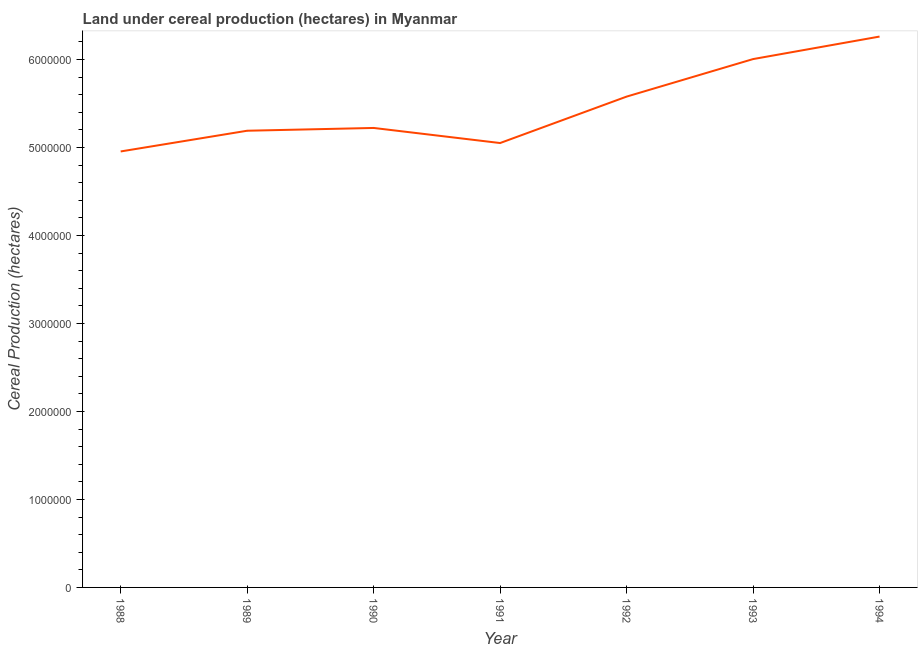What is the land under cereal production in 1988?
Your answer should be compact. 4.95e+06. Across all years, what is the maximum land under cereal production?
Ensure brevity in your answer.  6.26e+06. Across all years, what is the minimum land under cereal production?
Your answer should be compact. 4.95e+06. In which year was the land under cereal production maximum?
Give a very brief answer. 1994. In which year was the land under cereal production minimum?
Offer a terse response. 1988. What is the sum of the land under cereal production?
Keep it short and to the point. 3.83e+07. What is the difference between the land under cereal production in 1988 and 1994?
Your response must be concise. -1.31e+06. What is the average land under cereal production per year?
Offer a terse response. 5.47e+06. What is the median land under cereal production?
Offer a terse response. 5.22e+06. In how many years, is the land under cereal production greater than 1600000 hectares?
Your answer should be compact. 7. Do a majority of the years between 1993 and 1989 (inclusive) have land under cereal production greater than 400000 hectares?
Offer a very short reply. Yes. What is the ratio of the land under cereal production in 1991 to that in 1993?
Your answer should be very brief. 0.84. What is the difference between the highest and the second highest land under cereal production?
Offer a terse response. 2.56e+05. What is the difference between the highest and the lowest land under cereal production?
Keep it short and to the point. 1.31e+06. In how many years, is the land under cereal production greater than the average land under cereal production taken over all years?
Keep it short and to the point. 3. How many lines are there?
Ensure brevity in your answer.  1. How many years are there in the graph?
Keep it short and to the point. 7. Are the values on the major ticks of Y-axis written in scientific E-notation?
Ensure brevity in your answer.  No. What is the title of the graph?
Provide a short and direct response. Land under cereal production (hectares) in Myanmar. What is the label or title of the Y-axis?
Your response must be concise. Cereal Production (hectares). What is the Cereal Production (hectares) of 1988?
Offer a very short reply. 4.95e+06. What is the Cereal Production (hectares) in 1989?
Offer a very short reply. 5.19e+06. What is the Cereal Production (hectares) of 1990?
Your answer should be compact. 5.22e+06. What is the Cereal Production (hectares) in 1991?
Provide a short and direct response. 5.05e+06. What is the Cereal Production (hectares) of 1992?
Your answer should be compact. 5.58e+06. What is the Cereal Production (hectares) of 1993?
Ensure brevity in your answer.  6.00e+06. What is the Cereal Production (hectares) of 1994?
Offer a very short reply. 6.26e+06. What is the difference between the Cereal Production (hectares) in 1988 and 1989?
Offer a very short reply. -2.35e+05. What is the difference between the Cereal Production (hectares) in 1988 and 1990?
Your answer should be very brief. -2.67e+05. What is the difference between the Cereal Production (hectares) in 1988 and 1991?
Keep it short and to the point. -9.56e+04. What is the difference between the Cereal Production (hectares) in 1988 and 1992?
Provide a short and direct response. -6.23e+05. What is the difference between the Cereal Production (hectares) in 1988 and 1993?
Your response must be concise. -1.05e+06. What is the difference between the Cereal Production (hectares) in 1988 and 1994?
Make the answer very short. -1.31e+06. What is the difference between the Cereal Production (hectares) in 1989 and 1990?
Your response must be concise. -3.17e+04. What is the difference between the Cereal Production (hectares) in 1989 and 1991?
Ensure brevity in your answer.  1.40e+05. What is the difference between the Cereal Production (hectares) in 1989 and 1992?
Your answer should be very brief. -3.88e+05. What is the difference between the Cereal Production (hectares) in 1989 and 1993?
Provide a succinct answer. -8.14e+05. What is the difference between the Cereal Production (hectares) in 1989 and 1994?
Offer a very short reply. -1.07e+06. What is the difference between the Cereal Production (hectares) in 1990 and 1991?
Give a very brief answer. 1.71e+05. What is the difference between the Cereal Production (hectares) in 1990 and 1992?
Provide a short and direct response. -3.56e+05. What is the difference between the Cereal Production (hectares) in 1990 and 1993?
Keep it short and to the point. -7.83e+05. What is the difference between the Cereal Production (hectares) in 1990 and 1994?
Make the answer very short. -1.04e+06. What is the difference between the Cereal Production (hectares) in 1991 and 1992?
Offer a terse response. -5.28e+05. What is the difference between the Cereal Production (hectares) in 1991 and 1993?
Offer a terse response. -9.54e+05. What is the difference between the Cereal Production (hectares) in 1991 and 1994?
Your answer should be very brief. -1.21e+06. What is the difference between the Cereal Production (hectares) in 1992 and 1993?
Your response must be concise. -4.26e+05. What is the difference between the Cereal Production (hectares) in 1992 and 1994?
Ensure brevity in your answer.  -6.82e+05. What is the difference between the Cereal Production (hectares) in 1993 and 1994?
Make the answer very short. -2.56e+05. What is the ratio of the Cereal Production (hectares) in 1988 to that in 1989?
Provide a succinct answer. 0.95. What is the ratio of the Cereal Production (hectares) in 1988 to that in 1990?
Your response must be concise. 0.95. What is the ratio of the Cereal Production (hectares) in 1988 to that in 1992?
Keep it short and to the point. 0.89. What is the ratio of the Cereal Production (hectares) in 1988 to that in 1993?
Provide a short and direct response. 0.82. What is the ratio of the Cereal Production (hectares) in 1988 to that in 1994?
Offer a terse response. 0.79. What is the ratio of the Cereal Production (hectares) in 1989 to that in 1991?
Offer a very short reply. 1.03. What is the ratio of the Cereal Production (hectares) in 1989 to that in 1993?
Your answer should be very brief. 0.86. What is the ratio of the Cereal Production (hectares) in 1989 to that in 1994?
Keep it short and to the point. 0.83. What is the ratio of the Cereal Production (hectares) in 1990 to that in 1991?
Your answer should be compact. 1.03. What is the ratio of the Cereal Production (hectares) in 1990 to that in 1992?
Offer a terse response. 0.94. What is the ratio of the Cereal Production (hectares) in 1990 to that in 1993?
Make the answer very short. 0.87. What is the ratio of the Cereal Production (hectares) in 1990 to that in 1994?
Provide a short and direct response. 0.83. What is the ratio of the Cereal Production (hectares) in 1991 to that in 1992?
Provide a short and direct response. 0.91. What is the ratio of the Cereal Production (hectares) in 1991 to that in 1993?
Your response must be concise. 0.84. What is the ratio of the Cereal Production (hectares) in 1991 to that in 1994?
Give a very brief answer. 0.81. What is the ratio of the Cereal Production (hectares) in 1992 to that in 1993?
Make the answer very short. 0.93. What is the ratio of the Cereal Production (hectares) in 1992 to that in 1994?
Make the answer very short. 0.89. What is the ratio of the Cereal Production (hectares) in 1993 to that in 1994?
Provide a succinct answer. 0.96. 